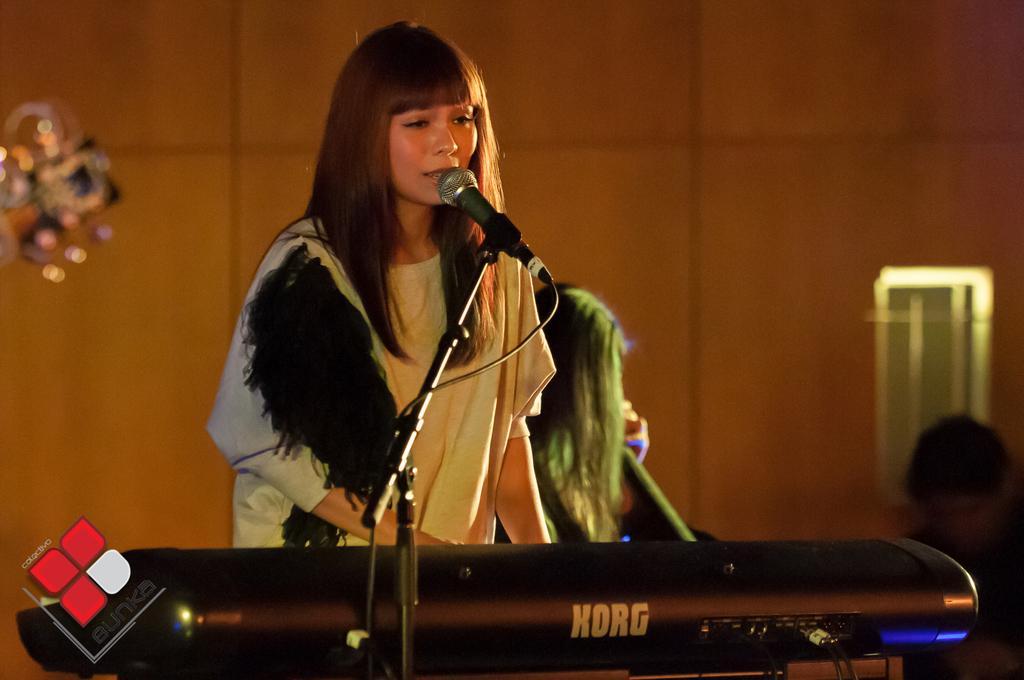How would you summarize this image in a sentence or two? In this image I can see a woman is standing in front of a microphone. Here I can see a musical instrument. In the background I can see a wall and people. Here I can see a watermark. 